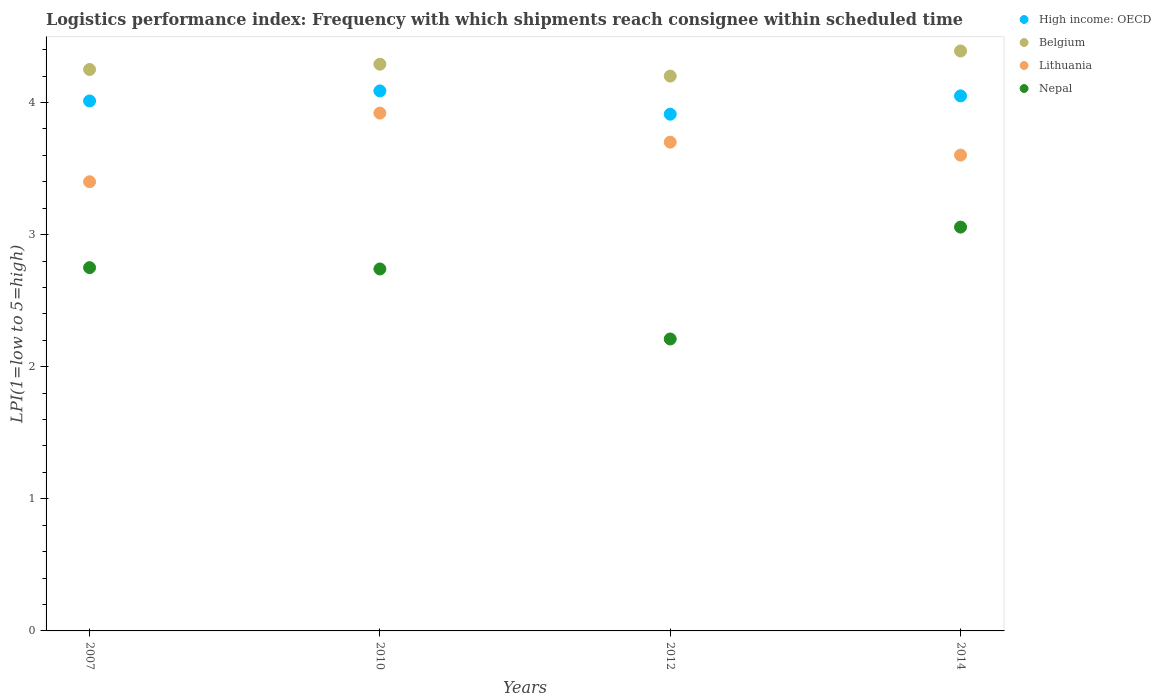How many different coloured dotlines are there?
Make the answer very short. 4. What is the logistics performance index in High income: OECD in 2014?
Ensure brevity in your answer.  4.05. Across all years, what is the maximum logistics performance index in Belgium?
Offer a very short reply. 4.39. Across all years, what is the minimum logistics performance index in High income: OECD?
Offer a terse response. 3.91. What is the total logistics performance index in High income: OECD in the graph?
Your answer should be very brief. 16.06. What is the difference between the logistics performance index in Lithuania in 2007 and that in 2014?
Ensure brevity in your answer.  -0.2. What is the difference between the logistics performance index in High income: OECD in 2014 and the logistics performance index in Nepal in 2012?
Provide a short and direct response. 1.84. What is the average logistics performance index in Lithuania per year?
Ensure brevity in your answer.  3.66. In the year 2007, what is the difference between the logistics performance index in Nepal and logistics performance index in High income: OECD?
Your response must be concise. -1.26. What is the ratio of the logistics performance index in Lithuania in 2010 to that in 2014?
Your answer should be very brief. 1.09. Is the logistics performance index in High income: OECD in 2007 less than that in 2012?
Make the answer very short. No. What is the difference between the highest and the second highest logistics performance index in High income: OECD?
Provide a succinct answer. 0.04. What is the difference between the highest and the lowest logistics performance index in Lithuania?
Give a very brief answer. 0.52. Is the sum of the logistics performance index in Belgium in 2007 and 2010 greater than the maximum logistics performance index in Nepal across all years?
Offer a very short reply. Yes. Does the logistics performance index in Lithuania monotonically increase over the years?
Make the answer very short. No. Is the logistics performance index in Nepal strictly greater than the logistics performance index in High income: OECD over the years?
Your answer should be very brief. No. Is the logistics performance index in Nepal strictly less than the logistics performance index in High income: OECD over the years?
Ensure brevity in your answer.  Yes. How many years are there in the graph?
Give a very brief answer. 4. Are the values on the major ticks of Y-axis written in scientific E-notation?
Provide a succinct answer. No. Does the graph contain any zero values?
Your response must be concise. No. Does the graph contain grids?
Provide a succinct answer. No. Where does the legend appear in the graph?
Your response must be concise. Top right. How many legend labels are there?
Provide a short and direct response. 4. How are the legend labels stacked?
Offer a terse response. Vertical. What is the title of the graph?
Provide a short and direct response. Logistics performance index: Frequency with which shipments reach consignee within scheduled time. What is the label or title of the X-axis?
Provide a short and direct response. Years. What is the label or title of the Y-axis?
Provide a short and direct response. LPI(1=low to 5=high). What is the LPI(1=low to 5=high) of High income: OECD in 2007?
Make the answer very short. 4.01. What is the LPI(1=low to 5=high) of Belgium in 2007?
Keep it short and to the point. 4.25. What is the LPI(1=low to 5=high) in Lithuania in 2007?
Your response must be concise. 3.4. What is the LPI(1=low to 5=high) of Nepal in 2007?
Offer a terse response. 2.75. What is the LPI(1=low to 5=high) of High income: OECD in 2010?
Keep it short and to the point. 4.09. What is the LPI(1=low to 5=high) in Belgium in 2010?
Offer a very short reply. 4.29. What is the LPI(1=low to 5=high) of Lithuania in 2010?
Provide a succinct answer. 3.92. What is the LPI(1=low to 5=high) in Nepal in 2010?
Keep it short and to the point. 2.74. What is the LPI(1=low to 5=high) in High income: OECD in 2012?
Your answer should be compact. 3.91. What is the LPI(1=low to 5=high) of Belgium in 2012?
Offer a terse response. 4.2. What is the LPI(1=low to 5=high) in Lithuania in 2012?
Ensure brevity in your answer.  3.7. What is the LPI(1=low to 5=high) of Nepal in 2012?
Your response must be concise. 2.21. What is the LPI(1=low to 5=high) in High income: OECD in 2014?
Your answer should be compact. 4.05. What is the LPI(1=low to 5=high) of Belgium in 2014?
Offer a terse response. 4.39. What is the LPI(1=low to 5=high) of Lithuania in 2014?
Your answer should be compact. 3.6. What is the LPI(1=low to 5=high) in Nepal in 2014?
Provide a succinct answer. 3.06. Across all years, what is the maximum LPI(1=low to 5=high) in High income: OECD?
Keep it short and to the point. 4.09. Across all years, what is the maximum LPI(1=low to 5=high) of Belgium?
Give a very brief answer. 4.39. Across all years, what is the maximum LPI(1=low to 5=high) in Lithuania?
Provide a short and direct response. 3.92. Across all years, what is the maximum LPI(1=low to 5=high) in Nepal?
Ensure brevity in your answer.  3.06. Across all years, what is the minimum LPI(1=low to 5=high) of High income: OECD?
Keep it short and to the point. 3.91. Across all years, what is the minimum LPI(1=low to 5=high) of Nepal?
Make the answer very short. 2.21. What is the total LPI(1=low to 5=high) of High income: OECD in the graph?
Ensure brevity in your answer.  16.06. What is the total LPI(1=low to 5=high) of Belgium in the graph?
Provide a short and direct response. 17.13. What is the total LPI(1=low to 5=high) in Lithuania in the graph?
Ensure brevity in your answer.  14.62. What is the total LPI(1=low to 5=high) of Nepal in the graph?
Make the answer very short. 10.76. What is the difference between the LPI(1=low to 5=high) in High income: OECD in 2007 and that in 2010?
Your answer should be compact. -0.08. What is the difference between the LPI(1=low to 5=high) of Belgium in 2007 and that in 2010?
Provide a short and direct response. -0.04. What is the difference between the LPI(1=low to 5=high) in Lithuania in 2007 and that in 2010?
Your response must be concise. -0.52. What is the difference between the LPI(1=low to 5=high) of Nepal in 2007 and that in 2010?
Your answer should be compact. 0.01. What is the difference between the LPI(1=low to 5=high) of High income: OECD in 2007 and that in 2012?
Offer a terse response. 0.1. What is the difference between the LPI(1=low to 5=high) in Belgium in 2007 and that in 2012?
Keep it short and to the point. 0.05. What is the difference between the LPI(1=low to 5=high) in Nepal in 2007 and that in 2012?
Ensure brevity in your answer.  0.54. What is the difference between the LPI(1=low to 5=high) in High income: OECD in 2007 and that in 2014?
Your answer should be very brief. -0.04. What is the difference between the LPI(1=low to 5=high) of Belgium in 2007 and that in 2014?
Provide a succinct answer. -0.14. What is the difference between the LPI(1=low to 5=high) of Lithuania in 2007 and that in 2014?
Provide a succinct answer. -0.2. What is the difference between the LPI(1=low to 5=high) of Nepal in 2007 and that in 2014?
Make the answer very short. -0.31. What is the difference between the LPI(1=low to 5=high) of High income: OECD in 2010 and that in 2012?
Ensure brevity in your answer.  0.18. What is the difference between the LPI(1=low to 5=high) of Belgium in 2010 and that in 2012?
Offer a terse response. 0.09. What is the difference between the LPI(1=low to 5=high) in Lithuania in 2010 and that in 2012?
Make the answer very short. 0.22. What is the difference between the LPI(1=low to 5=high) of Nepal in 2010 and that in 2012?
Ensure brevity in your answer.  0.53. What is the difference between the LPI(1=low to 5=high) in High income: OECD in 2010 and that in 2014?
Offer a terse response. 0.04. What is the difference between the LPI(1=low to 5=high) of Belgium in 2010 and that in 2014?
Provide a succinct answer. -0.1. What is the difference between the LPI(1=low to 5=high) in Lithuania in 2010 and that in 2014?
Offer a terse response. 0.32. What is the difference between the LPI(1=low to 5=high) of Nepal in 2010 and that in 2014?
Provide a succinct answer. -0.32. What is the difference between the LPI(1=low to 5=high) in High income: OECD in 2012 and that in 2014?
Keep it short and to the point. -0.14. What is the difference between the LPI(1=low to 5=high) in Belgium in 2012 and that in 2014?
Make the answer very short. -0.19. What is the difference between the LPI(1=low to 5=high) of Lithuania in 2012 and that in 2014?
Your answer should be compact. 0.1. What is the difference between the LPI(1=low to 5=high) of Nepal in 2012 and that in 2014?
Your answer should be very brief. -0.85. What is the difference between the LPI(1=low to 5=high) of High income: OECD in 2007 and the LPI(1=low to 5=high) of Belgium in 2010?
Ensure brevity in your answer.  -0.28. What is the difference between the LPI(1=low to 5=high) in High income: OECD in 2007 and the LPI(1=low to 5=high) in Lithuania in 2010?
Ensure brevity in your answer.  0.09. What is the difference between the LPI(1=low to 5=high) of High income: OECD in 2007 and the LPI(1=low to 5=high) of Nepal in 2010?
Your response must be concise. 1.27. What is the difference between the LPI(1=low to 5=high) of Belgium in 2007 and the LPI(1=low to 5=high) of Lithuania in 2010?
Ensure brevity in your answer.  0.33. What is the difference between the LPI(1=low to 5=high) of Belgium in 2007 and the LPI(1=low to 5=high) of Nepal in 2010?
Make the answer very short. 1.51. What is the difference between the LPI(1=low to 5=high) in Lithuania in 2007 and the LPI(1=low to 5=high) in Nepal in 2010?
Give a very brief answer. 0.66. What is the difference between the LPI(1=low to 5=high) in High income: OECD in 2007 and the LPI(1=low to 5=high) in Belgium in 2012?
Provide a short and direct response. -0.19. What is the difference between the LPI(1=low to 5=high) of High income: OECD in 2007 and the LPI(1=low to 5=high) of Lithuania in 2012?
Give a very brief answer. 0.31. What is the difference between the LPI(1=low to 5=high) of High income: OECD in 2007 and the LPI(1=low to 5=high) of Nepal in 2012?
Make the answer very short. 1.8. What is the difference between the LPI(1=low to 5=high) of Belgium in 2007 and the LPI(1=low to 5=high) of Lithuania in 2012?
Provide a succinct answer. 0.55. What is the difference between the LPI(1=low to 5=high) of Belgium in 2007 and the LPI(1=low to 5=high) of Nepal in 2012?
Keep it short and to the point. 2.04. What is the difference between the LPI(1=low to 5=high) of Lithuania in 2007 and the LPI(1=low to 5=high) of Nepal in 2012?
Offer a terse response. 1.19. What is the difference between the LPI(1=low to 5=high) of High income: OECD in 2007 and the LPI(1=low to 5=high) of Belgium in 2014?
Provide a short and direct response. -0.38. What is the difference between the LPI(1=low to 5=high) of High income: OECD in 2007 and the LPI(1=low to 5=high) of Lithuania in 2014?
Make the answer very short. 0.41. What is the difference between the LPI(1=low to 5=high) of High income: OECD in 2007 and the LPI(1=low to 5=high) of Nepal in 2014?
Provide a short and direct response. 0.96. What is the difference between the LPI(1=low to 5=high) in Belgium in 2007 and the LPI(1=low to 5=high) in Lithuania in 2014?
Make the answer very short. 0.65. What is the difference between the LPI(1=low to 5=high) of Belgium in 2007 and the LPI(1=low to 5=high) of Nepal in 2014?
Your answer should be compact. 1.19. What is the difference between the LPI(1=low to 5=high) in Lithuania in 2007 and the LPI(1=low to 5=high) in Nepal in 2014?
Make the answer very short. 0.34. What is the difference between the LPI(1=low to 5=high) of High income: OECD in 2010 and the LPI(1=low to 5=high) of Belgium in 2012?
Provide a succinct answer. -0.11. What is the difference between the LPI(1=low to 5=high) in High income: OECD in 2010 and the LPI(1=low to 5=high) in Lithuania in 2012?
Give a very brief answer. 0.39. What is the difference between the LPI(1=low to 5=high) of High income: OECD in 2010 and the LPI(1=low to 5=high) of Nepal in 2012?
Provide a short and direct response. 1.88. What is the difference between the LPI(1=low to 5=high) in Belgium in 2010 and the LPI(1=low to 5=high) in Lithuania in 2012?
Give a very brief answer. 0.59. What is the difference between the LPI(1=low to 5=high) in Belgium in 2010 and the LPI(1=low to 5=high) in Nepal in 2012?
Give a very brief answer. 2.08. What is the difference between the LPI(1=low to 5=high) in Lithuania in 2010 and the LPI(1=low to 5=high) in Nepal in 2012?
Your answer should be compact. 1.71. What is the difference between the LPI(1=low to 5=high) in High income: OECD in 2010 and the LPI(1=low to 5=high) in Belgium in 2014?
Make the answer very short. -0.3. What is the difference between the LPI(1=low to 5=high) of High income: OECD in 2010 and the LPI(1=low to 5=high) of Lithuania in 2014?
Provide a short and direct response. 0.49. What is the difference between the LPI(1=low to 5=high) of High income: OECD in 2010 and the LPI(1=low to 5=high) of Nepal in 2014?
Provide a short and direct response. 1.03. What is the difference between the LPI(1=low to 5=high) of Belgium in 2010 and the LPI(1=low to 5=high) of Lithuania in 2014?
Offer a terse response. 0.69. What is the difference between the LPI(1=low to 5=high) in Belgium in 2010 and the LPI(1=low to 5=high) in Nepal in 2014?
Your answer should be very brief. 1.23. What is the difference between the LPI(1=low to 5=high) in Lithuania in 2010 and the LPI(1=low to 5=high) in Nepal in 2014?
Your answer should be compact. 0.86. What is the difference between the LPI(1=low to 5=high) in High income: OECD in 2012 and the LPI(1=low to 5=high) in Belgium in 2014?
Provide a succinct answer. -0.48. What is the difference between the LPI(1=low to 5=high) in High income: OECD in 2012 and the LPI(1=low to 5=high) in Lithuania in 2014?
Offer a terse response. 0.31. What is the difference between the LPI(1=low to 5=high) of High income: OECD in 2012 and the LPI(1=low to 5=high) of Nepal in 2014?
Offer a terse response. 0.85. What is the difference between the LPI(1=low to 5=high) in Belgium in 2012 and the LPI(1=low to 5=high) in Lithuania in 2014?
Offer a very short reply. 0.6. What is the difference between the LPI(1=low to 5=high) in Belgium in 2012 and the LPI(1=low to 5=high) in Nepal in 2014?
Give a very brief answer. 1.14. What is the difference between the LPI(1=low to 5=high) of Lithuania in 2012 and the LPI(1=low to 5=high) of Nepal in 2014?
Make the answer very short. 0.64. What is the average LPI(1=low to 5=high) in High income: OECD per year?
Ensure brevity in your answer.  4.02. What is the average LPI(1=low to 5=high) of Belgium per year?
Offer a terse response. 4.28. What is the average LPI(1=low to 5=high) in Lithuania per year?
Make the answer very short. 3.66. What is the average LPI(1=low to 5=high) in Nepal per year?
Offer a very short reply. 2.69. In the year 2007, what is the difference between the LPI(1=low to 5=high) in High income: OECD and LPI(1=low to 5=high) in Belgium?
Make the answer very short. -0.24. In the year 2007, what is the difference between the LPI(1=low to 5=high) in High income: OECD and LPI(1=low to 5=high) in Lithuania?
Give a very brief answer. 0.61. In the year 2007, what is the difference between the LPI(1=low to 5=high) in High income: OECD and LPI(1=low to 5=high) in Nepal?
Make the answer very short. 1.26. In the year 2007, what is the difference between the LPI(1=low to 5=high) of Lithuania and LPI(1=low to 5=high) of Nepal?
Keep it short and to the point. 0.65. In the year 2010, what is the difference between the LPI(1=low to 5=high) in High income: OECD and LPI(1=low to 5=high) in Belgium?
Provide a succinct answer. -0.2. In the year 2010, what is the difference between the LPI(1=low to 5=high) in High income: OECD and LPI(1=low to 5=high) in Lithuania?
Ensure brevity in your answer.  0.17. In the year 2010, what is the difference between the LPI(1=low to 5=high) of High income: OECD and LPI(1=low to 5=high) of Nepal?
Provide a short and direct response. 1.35. In the year 2010, what is the difference between the LPI(1=low to 5=high) of Belgium and LPI(1=low to 5=high) of Lithuania?
Make the answer very short. 0.37. In the year 2010, what is the difference between the LPI(1=low to 5=high) of Belgium and LPI(1=low to 5=high) of Nepal?
Your answer should be compact. 1.55. In the year 2010, what is the difference between the LPI(1=low to 5=high) in Lithuania and LPI(1=low to 5=high) in Nepal?
Your answer should be very brief. 1.18. In the year 2012, what is the difference between the LPI(1=low to 5=high) in High income: OECD and LPI(1=low to 5=high) in Belgium?
Your response must be concise. -0.29. In the year 2012, what is the difference between the LPI(1=low to 5=high) in High income: OECD and LPI(1=low to 5=high) in Lithuania?
Give a very brief answer. 0.21. In the year 2012, what is the difference between the LPI(1=low to 5=high) of High income: OECD and LPI(1=low to 5=high) of Nepal?
Offer a very short reply. 1.7. In the year 2012, what is the difference between the LPI(1=low to 5=high) in Belgium and LPI(1=low to 5=high) in Lithuania?
Provide a short and direct response. 0.5. In the year 2012, what is the difference between the LPI(1=low to 5=high) in Belgium and LPI(1=low to 5=high) in Nepal?
Your answer should be very brief. 1.99. In the year 2012, what is the difference between the LPI(1=low to 5=high) of Lithuania and LPI(1=low to 5=high) of Nepal?
Give a very brief answer. 1.49. In the year 2014, what is the difference between the LPI(1=low to 5=high) in High income: OECD and LPI(1=low to 5=high) in Belgium?
Your answer should be very brief. -0.34. In the year 2014, what is the difference between the LPI(1=low to 5=high) of High income: OECD and LPI(1=low to 5=high) of Lithuania?
Offer a terse response. 0.45. In the year 2014, what is the difference between the LPI(1=low to 5=high) of High income: OECD and LPI(1=low to 5=high) of Nepal?
Provide a succinct answer. 0.99. In the year 2014, what is the difference between the LPI(1=low to 5=high) of Belgium and LPI(1=low to 5=high) of Lithuania?
Give a very brief answer. 0.79. In the year 2014, what is the difference between the LPI(1=low to 5=high) of Belgium and LPI(1=low to 5=high) of Nepal?
Make the answer very short. 1.33. In the year 2014, what is the difference between the LPI(1=low to 5=high) in Lithuania and LPI(1=low to 5=high) in Nepal?
Offer a terse response. 0.54. What is the ratio of the LPI(1=low to 5=high) in High income: OECD in 2007 to that in 2010?
Your response must be concise. 0.98. What is the ratio of the LPI(1=low to 5=high) in Belgium in 2007 to that in 2010?
Your answer should be very brief. 0.99. What is the ratio of the LPI(1=low to 5=high) of Lithuania in 2007 to that in 2010?
Provide a short and direct response. 0.87. What is the ratio of the LPI(1=low to 5=high) of High income: OECD in 2007 to that in 2012?
Give a very brief answer. 1.03. What is the ratio of the LPI(1=low to 5=high) of Belgium in 2007 to that in 2012?
Ensure brevity in your answer.  1.01. What is the ratio of the LPI(1=low to 5=high) in Lithuania in 2007 to that in 2012?
Ensure brevity in your answer.  0.92. What is the ratio of the LPI(1=low to 5=high) of Nepal in 2007 to that in 2012?
Your answer should be compact. 1.24. What is the ratio of the LPI(1=low to 5=high) in High income: OECD in 2007 to that in 2014?
Make the answer very short. 0.99. What is the ratio of the LPI(1=low to 5=high) of Belgium in 2007 to that in 2014?
Your answer should be compact. 0.97. What is the ratio of the LPI(1=low to 5=high) of Lithuania in 2007 to that in 2014?
Ensure brevity in your answer.  0.94. What is the ratio of the LPI(1=low to 5=high) in Nepal in 2007 to that in 2014?
Give a very brief answer. 0.9. What is the ratio of the LPI(1=low to 5=high) of High income: OECD in 2010 to that in 2012?
Your response must be concise. 1.04. What is the ratio of the LPI(1=low to 5=high) of Belgium in 2010 to that in 2012?
Your answer should be compact. 1.02. What is the ratio of the LPI(1=low to 5=high) of Lithuania in 2010 to that in 2012?
Provide a short and direct response. 1.06. What is the ratio of the LPI(1=low to 5=high) in Nepal in 2010 to that in 2012?
Your answer should be very brief. 1.24. What is the ratio of the LPI(1=low to 5=high) in High income: OECD in 2010 to that in 2014?
Ensure brevity in your answer.  1.01. What is the ratio of the LPI(1=low to 5=high) of Belgium in 2010 to that in 2014?
Offer a very short reply. 0.98. What is the ratio of the LPI(1=low to 5=high) in Lithuania in 2010 to that in 2014?
Provide a short and direct response. 1.09. What is the ratio of the LPI(1=low to 5=high) in Nepal in 2010 to that in 2014?
Keep it short and to the point. 0.9. What is the ratio of the LPI(1=low to 5=high) in High income: OECD in 2012 to that in 2014?
Make the answer very short. 0.97. What is the ratio of the LPI(1=low to 5=high) of Belgium in 2012 to that in 2014?
Keep it short and to the point. 0.96. What is the ratio of the LPI(1=low to 5=high) in Lithuania in 2012 to that in 2014?
Provide a succinct answer. 1.03. What is the ratio of the LPI(1=low to 5=high) in Nepal in 2012 to that in 2014?
Keep it short and to the point. 0.72. What is the difference between the highest and the second highest LPI(1=low to 5=high) of High income: OECD?
Provide a short and direct response. 0.04. What is the difference between the highest and the second highest LPI(1=low to 5=high) in Belgium?
Provide a short and direct response. 0.1. What is the difference between the highest and the second highest LPI(1=low to 5=high) of Lithuania?
Keep it short and to the point. 0.22. What is the difference between the highest and the second highest LPI(1=low to 5=high) of Nepal?
Keep it short and to the point. 0.31. What is the difference between the highest and the lowest LPI(1=low to 5=high) in High income: OECD?
Provide a short and direct response. 0.18. What is the difference between the highest and the lowest LPI(1=low to 5=high) of Belgium?
Offer a very short reply. 0.19. What is the difference between the highest and the lowest LPI(1=low to 5=high) in Lithuania?
Give a very brief answer. 0.52. What is the difference between the highest and the lowest LPI(1=low to 5=high) of Nepal?
Ensure brevity in your answer.  0.85. 